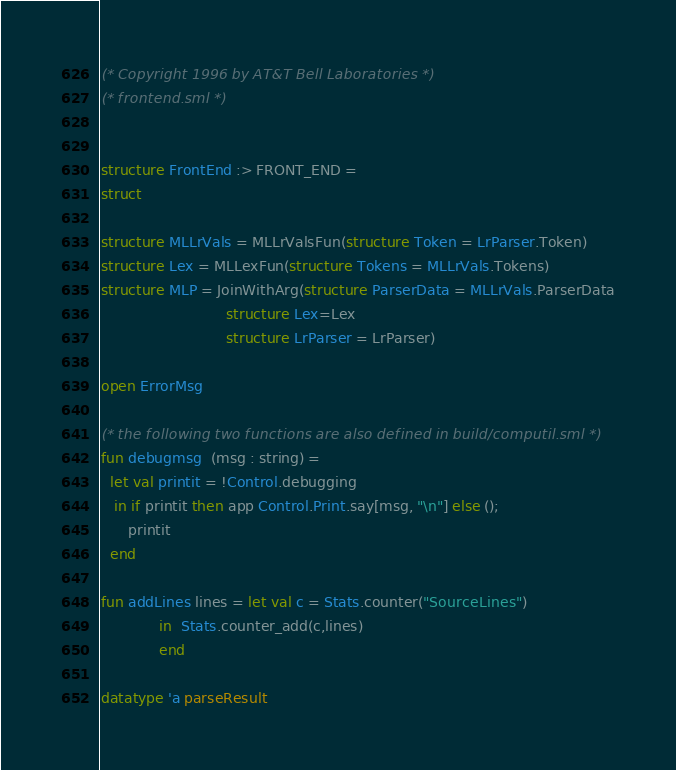<code> <loc_0><loc_0><loc_500><loc_500><_SML_>(* Copyright 1996 by AT&T Bell Laboratories *)
(* frontend.sml *)


structure FrontEnd :> FRONT_END =
struct

structure MLLrVals = MLLrValsFun(structure Token = LrParser.Token)
structure Lex = MLLexFun(structure Tokens = MLLrVals.Tokens)
structure MLP = JoinWithArg(structure ParserData = MLLrVals.ParserData
                            structure Lex=Lex
                            structure LrParser = LrParser)

open ErrorMsg

(* the following two functions are also defined in build/computil.sml *)
fun debugmsg  (msg : string) =
  let val printit = !Control.debugging
   in if printit then app Control.Print.say[msg, "\n"] else ();
      printit
  end

fun addLines lines = let val c = Stats.counter("SourceLines")
		     in  Stats.counter_add(c,lines)
		     end

datatype 'a parseResult</code> 